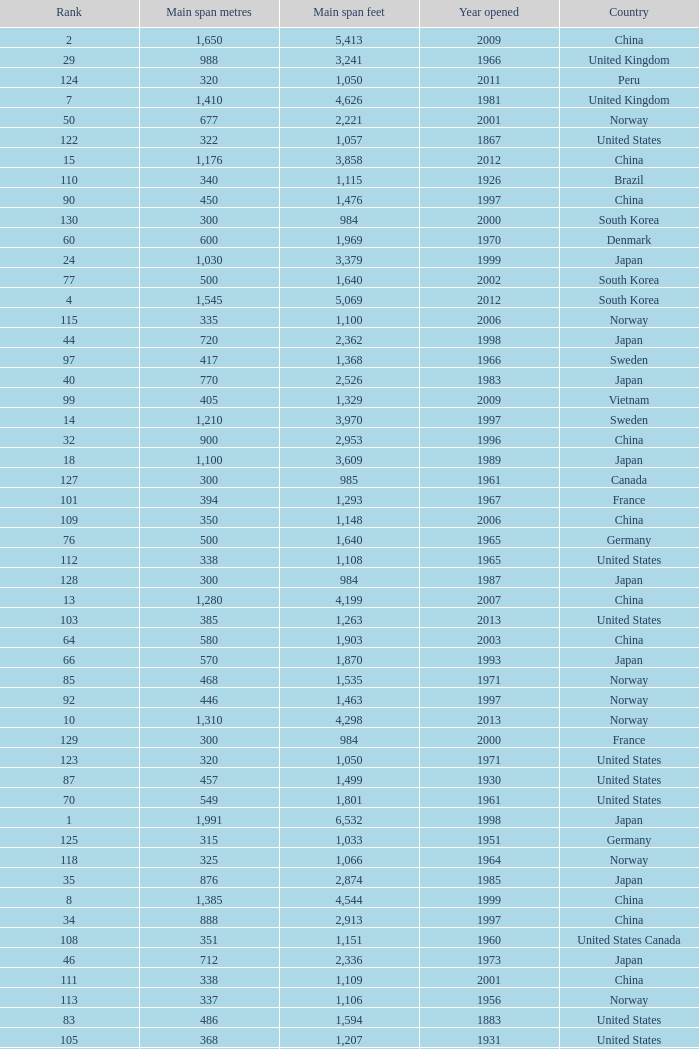What is the main span feet from opening year of 1936 in the United States with a rank greater than 47 and 421 main span metres? 1381.0. Can you give me this table as a dict? {'header': ['Rank', 'Main span metres', 'Main span feet', 'Year opened', 'Country'], 'rows': [['2', '1,650', '5,413', '2009', 'China'], ['29', '988', '3,241', '1966', 'United Kingdom'], ['124', '320', '1,050', '2011', 'Peru'], ['7', '1,410', '4,626', '1981', 'United Kingdom'], ['50', '677', '2,221', '2001', 'Norway'], ['122', '322', '1,057', '1867', 'United States'], ['15', '1,176', '3,858', '2012', 'China'], ['110', '340', '1,115', '1926', 'Brazil'], ['90', '450', '1,476', '1997', 'China'], ['130', '300', '984', '2000', 'South Korea'], ['60', '600', '1,969', '1970', 'Denmark'], ['24', '1,030', '3,379', '1999', 'Japan'], ['77', '500', '1,640', '2002', 'South Korea'], ['4', '1,545', '5,069', '2012', 'South Korea'], ['115', '335', '1,100', '2006', 'Norway'], ['44', '720', '2,362', '1998', 'Japan'], ['97', '417', '1,368', '1966', 'Sweden'], ['40', '770', '2,526', '1983', 'Japan'], ['99', '405', '1,329', '2009', 'Vietnam'], ['14', '1,210', '3,970', '1997', 'Sweden'], ['32', '900', '2,953', '1996', 'China'], ['18', '1,100', '3,609', '1989', 'Japan'], ['127', '300', '985', '1961', 'Canada'], ['101', '394', '1,293', '1967', 'France'], ['109', '350', '1,148', '2006', 'China'], ['76', '500', '1,640', '1965', 'Germany'], ['112', '338', '1,108', '1965', 'United States'], ['128', '300', '984', '1987', 'Japan'], ['13', '1,280', '4,199', '2007', 'China'], ['103', '385', '1,263', '2013', 'United States'], ['64', '580', '1,903', '2003', 'China'], ['66', '570', '1,870', '1993', 'Japan'], ['85', '468', '1,535', '1971', 'Norway'], ['92', '446', '1,463', '1997', 'Norway'], ['10', '1,310', '4,298', '2013', 'Norway'], ['129', '300', '984', '2000', 'France'], ['123', '320', '1,050', '1971', 'United States'], ['87', '457', '1,499', '1930', 'United States'], ['70', '549', '1,801', '1961', 'United States'], ['1', '1,991', '6,532', '1998', 'Japan'], ['125', '315', '1,033', '1951', 'Germany'], ['118', '325', '1,066', '1964', 'Norway'], ['35', '876', '2,874', '1985', 'Japan'], ['8', '1,385', '4,544', '1999', 'China'], ['34', '888', '2,913', '1997', 'China'], ['108', '351', '1,151', '1960', 'United States Canada'], ['46', '712', '2,336', '1973', 'Japan'], ['111', '338', '1,109', '2001', 'China'], ['113', '337', '1,106', '1956', 'Norway'], ['83', '486', '1,594', '1883', 'United States'], ['105', '368', '1,207', '1931', 'United States'], ['120', '323', '1,060', '1932', 'United States'], ['38', '850', '2,789', '1992', 'Norway'], ['79', '488', '1,601', '1903', 'United States'], ['102', '390', '1,280', '1964', 'Uzbekistan'], ['116', '329', '1,088', '1939', 'United States'], ['49', '701', '2,300', '1939', 'United States'], ['71', '540', '1,772', '2008', 'Japan'], ['51', '668', '2,192', '1969', 'Canada'], ['86', '465', '1,526', '1977', 'Japan'], ['88', '457', '1,499', '1963', 'United States'], ['56', '623', '2,044', '1992', 'Norway'], ['47', '704', '2,310', '1936', 'United States'], ['59', '608', '1,995', '1959', 'France'], ['93', '441', '1,447', '1955', 'Canada'], ['41', '750', '2,461', '2000', 'Japan'], ['95', '427', '1,401', '1970', 'Canada'], ['69', '560', '1,837', '2001', 'China'], ['37', '853', '2,799', '2007', 'United States'], ['117', '328', '1,085', '1939', 'Zambia Zimbabwe'], ['89', '452', '1,483', '1995', 'China'], ['5', '1,490', '4,888', '2005', 'China'], ['36', '853', '2,799', '1950', 'United States'], ['6', '1,418', '4,652', '2012', 'China'], ['61', '600', '1,969', '1999', 'Japan'], ['31', '940', '3,084', '1988', 'Japan'], ['53', '656', '2152', '1951', 'United States'], ['65', '577', '1,893', '2001', 'Norway'], ['42', '750', '2,461', '2000', 'Kazakhstan'], ['45', '712', '2,336', '1967', 'Venezuela'], ['9', '1,377', '4,518', '1997', 'Hong Kong'], ['22', '1,074', '3,524', '1973', 'Turkey'], ['63', '595', '1,952', '1997', 'Norway'], ['91', '448', '1,470', '1909', 'United States'], ['3', '1,624', '5,328', '1998', 'Denmark'], ['58', '610', '2,001', '1957', 'United States'], ['25', '1,020', '3,346', '1999', 'Japan'], ['52', '656', '2,152', '1968', 'United States'], ['80', '488', '1,601', '1969', 'United States'], ['72', '534', '1,752', '1926', 'United States'], ['16', '1,158', '3,799', '1957', 'United States'], ['20', '1,088', '3,570', '2009', 'China'], ['43', '728', '2,388', '2003', 'United States'], ['119', '325', '1,066', '1981', 'Norway'], ['67', '564', '1,850', '1929', 'United States Canada'], ['39', '820', '2,690', '2012', 'China'], ['48', '704', '2,310', '1936', 'United States'], ['55', '636', '2,087', '2009', 'China'], ['81', '488', '1,601', '1952', 'United States'], ['107', '366', '1,200', '1929', 'United States'], ['19', '1,090', '3,576', '1988', 'Turkey'], ['62', '600', '1,969', '2000', 'China'], ['27', '1,006', '3,301', '1964', 'United Kingdom'], ['96', '421', '1,381', '1936', 'United States'], ['104', '378', '1,240', '1954', 'Germany'], ['28', '990', '3,248', '1988', 'Japan'], ['82', '488', '1,601', '1973', 'United States'], ['98', '408', '1339', '2010', 'China'], ['106', '367', '1,204', '1962', 'Japan'], ['73', '525', '1,722', '1972', 'Norway'], ['21', '1,080 (x2)', '3,543 (x2)', '2012', 'China'], ['23', '1,067', '3,501', '1931', 'United States'], ['12', '1,280', '4,200', '1937', 'United States'], ['54', '648', '2,126', '1999', 'China'], ['68', '560', '1,837', '1988', 'Japan'], ['114', '335', '1,100', '1961', 'United Kingdom'], ['74', '525', '1,722', '1977', 'Norway'], ['100', '404', '1,325', '1973', 'South Korea'], ['78', '497', '1,631', '1924', 'United States'], ['11', '1,298', '4,260', '1964', 'United States'], ['30', '960', '3,150', '2001', 'China'], ['121', '323', '1,059', '1936', 'Canada'], ['84', '473', '1,552', '1938', 'Canada'], ['26', '1,013', '3,323', '1966', 'Portugal'], ['17', '1,108', '3,635', '2008', 'China'], ['75', '520', '1,706', '1983', 'Democratic Republic of the Congo'], ['33', '900', '2,953', '2009', 'China'], ['94', '430', '1,411', '2012', 'China'], ['126', '308', '1,010', '1849', 'United States'], ['57', '616', '2,021', '2009', 'China']]} 